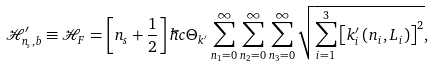Convert formula to latex. <formula><loc_0><loc_0><loc_500><loc_500>\mathcal { H } ^ { \prime } _ { n _ { s } , b } & \equiv \mathcal { H } _ { F } = \left [ n _ { s } + \frac { 1 } { 2 } \right ] \hbar { c } \Theta _ { k ^ { \prime } } \sum _ { n _ { 1 } = 0 } ^ { \infty } \sum _ { n _ { 2 } = 0 } ^ { \infty } \sum _ { n _ { 3 } = 0 } ^ { \infty } \sqrt { \sum _ { i = 1 } ^ { 3 } \left [ k ^ { \prime } _ { i } \left ( n _ { i } , L _ { i } \right ) \right ] ^ { 2 } } ,</formula> 